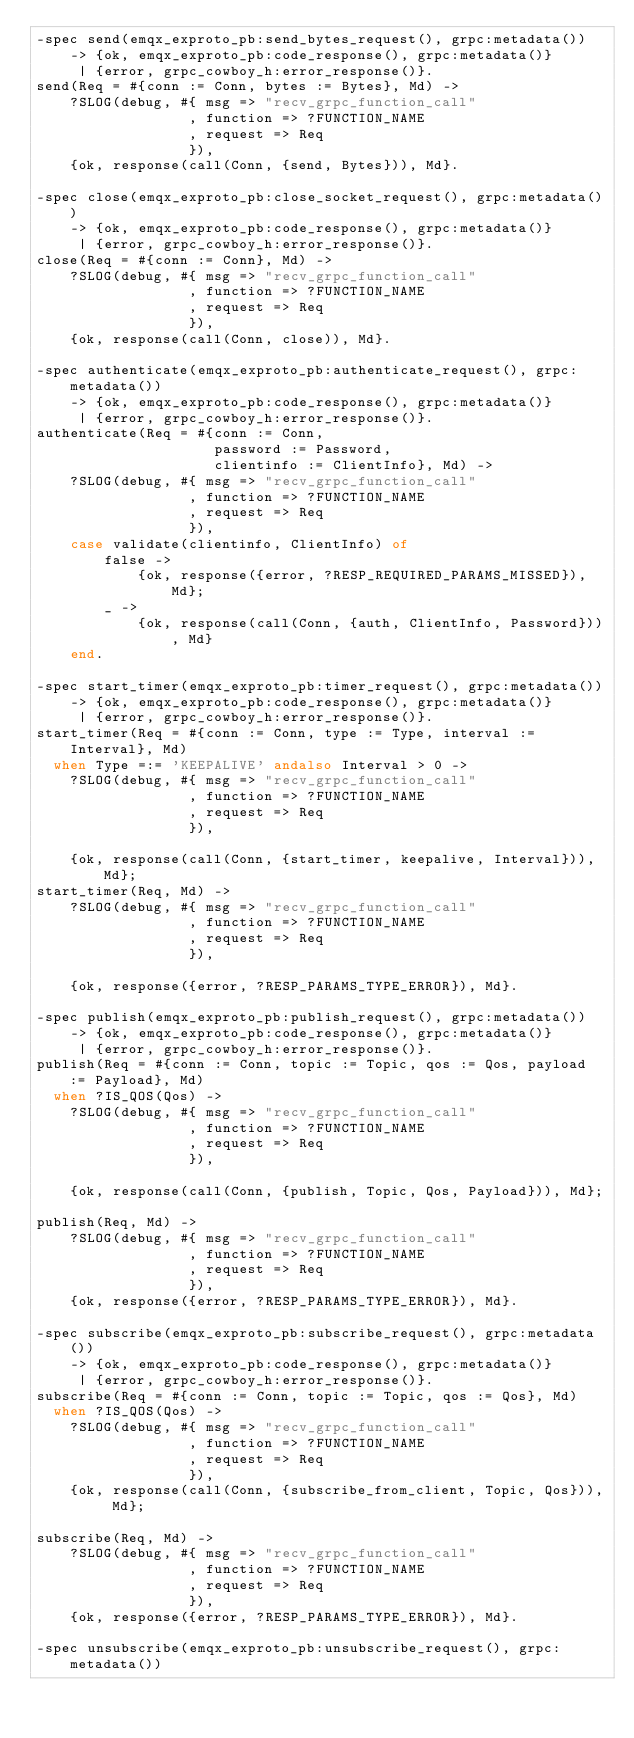<code> <loc_0><loc_0><loc_500><loc_500><_Erlang_>-spec send(emqx_exproto_pb:send_bytes_request(), grpc:metadata())
    -> {ok, emqx_exproto_pb:code_response(), grpc:metadata()}
     | {error, grpc_cowboy_h:error_response()}.
send(Req = #{conn := Conn, bytes := Bytes}, Md) ->
    ?SLOG(debug, #{ msg => "recv_grpc_function_call"
                  , function => ?FUNCTION_NAME
                  , request => Req
                  }),
    {ok, response(call(Conn, {send, Bytes})), Md}.

-spec close(emqx_exproto_pb:close_socket_request(), grpc:metadata())
    -> {ok, emqx_exproto_pb:code_response(), grpc:metadata()}
     | {error, grpc_cowboy_h:error_response()}.
close(Req = #{conn := Conn}, Md) ->
    ?SLOG(debug, #{ msg => "recv_grpc_function_call"
                  , function => ?FUNCTION_NAME
                  , request => Req
                  }),
    {ok, response(call(Conn, close)), Md}.

-spec authenticate(emqx_exproto_pb:authenticate_request(), grpc:metadata())
    -> {ok, emqx_exproto_pb:code_response(), grpc:metadata()}
     | {error, grpc_cowboy_h:error_response()}.
authenticate(Req = #{conn := Conn,
                     password := Password,
                     clientinfo := ClientInfo}, Md) ->
    ?SLOG(debug, #{ msg => "recv_grpc_function_call"
                  , function => ?FUNCTION_NAME
                  , request => Req
                  }),
    case validate(clientinfo, ClientInfo) of
        false ->
            {ok, response({error, ?RESP_REQUIRED_PARAMS_MISSED}), Md};
        _ ->
            {ok, response(call(Conn, {auth, ClientInfo, Password})), Md}
    end.

-spec start_timer(emqx_exproto_pb:timer_request(), grpc:metadata())
    -> {ok, emqx_exproto_pb:code_response(), grpc:metadata()}
     | {error, grpc_cowboy_h:error_response()}.
start_timer(Req = #{conn := Conn, type := Type, interval := Interval}, Md)
  when Type =:= 'KEEPALIVE' andalso Interval > 0 ->
    ?SLOG(debug, #{ msg => "recv_grpc_function_call"
                  , function => ?FUNCTION_NAME
                  , request => Req
                  }),

    {ok, response(call(Conn, {start_timer, keepalive, Interval})), Md};
start_timer(Req, Md) ->
    ?SLOG(debug, #{ msg => "recv_grpc_function_call"
                  , function => ?FUNCTION_NAME
                  , request => Req
                  }),

    {ok, response({error, ?RESP_PARAMS_TYPE_ERROR}), Md}.

-spec publish(emqx_exproto_pb:publish_request(), grpc:metadata())
    -> {ok, emqx_exproto_pb:code_response(), grpc:metadata()}
     | {error, grpc_cowboy_h:error_response()}.
publish(Req = #{conn := Conn, topic := Topic, qos := Qos, payload := Payload}, Md)
  when ?IS_QOS(Qos) ->
    ?SLOG(debug, #{ msg => "recv_grpc_function_call"
                  , function => ?FUNCTION_NAME
                  , request => Req
                  }),

    {ok, response(call(Conn, {publish, Topic, Qos, Payload})), Md};

publish(Req, Md) ->
    ?SLOG(debug, #{ msg => "recv_grpc_function_call"
                  , function => ?FUNCTION_NAME
                  , request => Req
                  }),
    {ok, response({error, ?RESP_PARAMS_TYPE_ERROR}), Md}.

-spec subscribe(emqx_exproto_pb:subscribe_request(), grpc:metadata())
    -> {ok, emqx_exproto_pb:code_response(), grpc:metadata()}
     | {error, grpc_cowboy_h:error_response()}.
subscribe(Req = #{conn := Conn, topic := Topic, qos := Qos}, Md)
  when ?IS_QOS(Qos) ->
    ?SLOG(debug, #{ msg => "recv_grpc_function_call"
                  , function => ?FUNCTION_NAME
                  , request => Req
                  }),
    {ok, response(call(Conn, {subscribe_from_client, Topic, Qos})), Md};

subscribe(Req, Md) ->
    ?SLOG(debug, #{ msg => "recv_grpc_function_call"
                  , function => ?FUNCTION_NAME
                  , request => Req
                  }),
    {ok, response({error, ?RESP_PARAMS_TYPE_ERROR}), Md}.

-spec unsubscribe(emqx_exproto_pb:unsubscribe_request(), grpc:metadata())</code> 